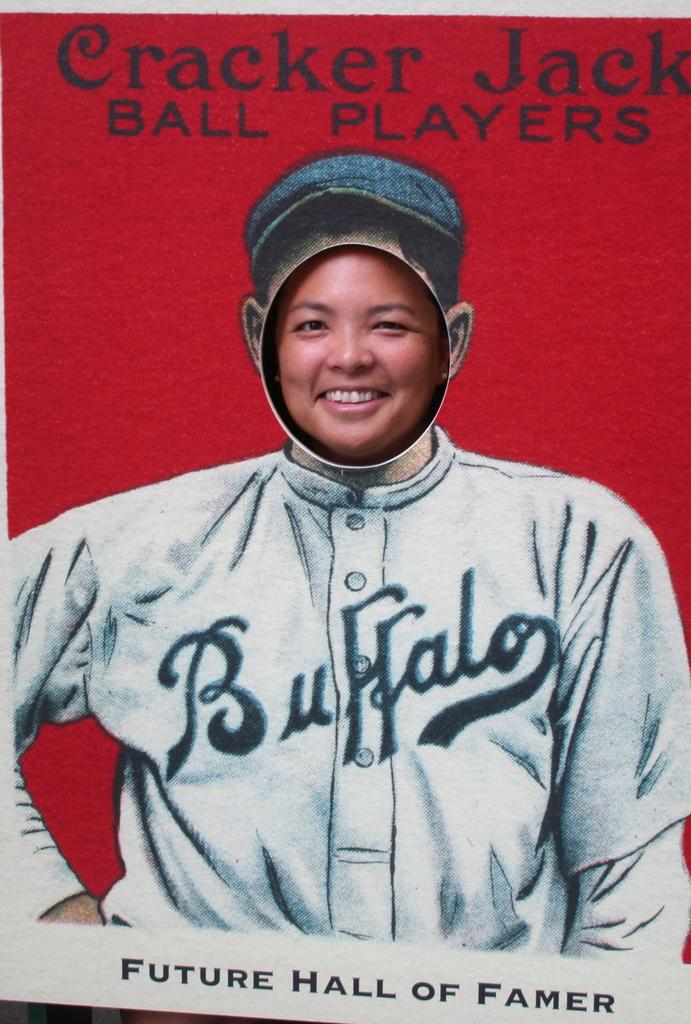Provide a one-sentence caption for the provided image. A woman taking a photo in a picture of a Buffalo baseball player. 